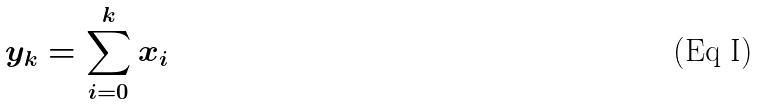Convert formula to latex. <formula><loc_0><loc_0><loc_500><loc_500>y _ { k } = \sum _ { i = 0 } ^ { k } x _ { i }</formula> 